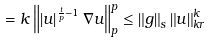Convert formula to latex. <formula><loc_0><loc_0><loc_500><loc_500>= k \left \| \left | u \right | ^ { \frac { t } { p } - 1 } \nabla u \right \| _ { p } ^ { p } \leq \left \| g \right \| _ { s } \left \| u \right \| _ { k r } ^ { k }</formula> 